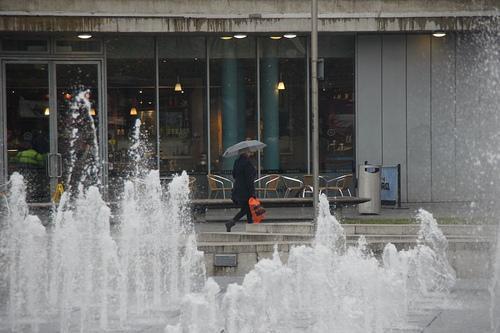How many panes of glass are there?
Give a very brief answer. 7. 